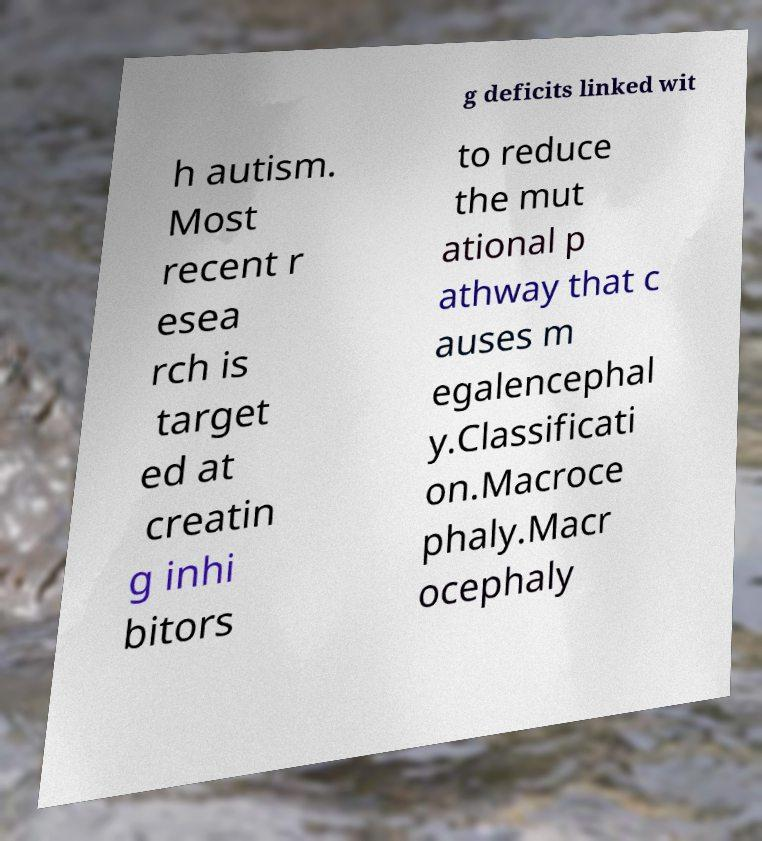I need the written content from this picture converted into text. Can you do that? g deficits linked wit h autism. Most recent r esea rch is target ed at creatin g inhi bitors to reduce the mut ational p athway that c auses m egalencephal y.Classificati on.Macroce phaly.Macr ocephaly 